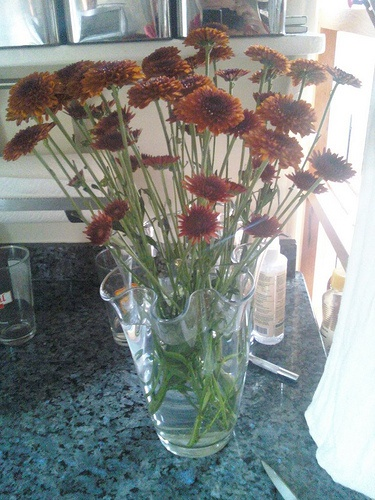Describe the objects in this image and their specific colors. I can see vase in lightblue, teal, darkgray, and gray tones, cup in lightblue, black, gray, and purple tones, bottle in lightblue, lightgray, and darkgray tones, bottle in lightblue, lightgray, darkgray, and tan tones, and cup in lightblue, gray, black, and darkgray tones in this image. 